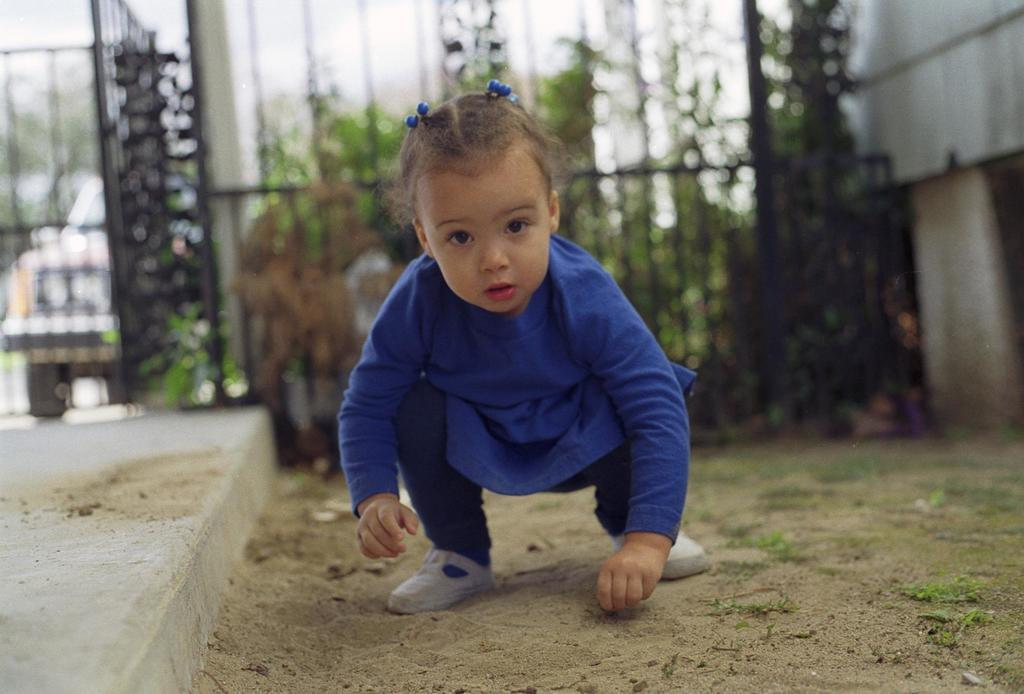What is the main subject of the image? There is a kid in the image. What position is the kid in? The kid is in a squat position on the ground. What can be seen in the background of the image? There are grills, vehicles, plants, a wall, and the sky visible in the background of the image. How many cherries can be seen on the kid's elbow in the image? There are no cherries present in the image, and the kid's elbow is not visible. Can you tell me how many jellyfish are swimming in the sky in the image? There are no jellyfish present in the image, and the sky is visible but not occupied by any marine creatures. 